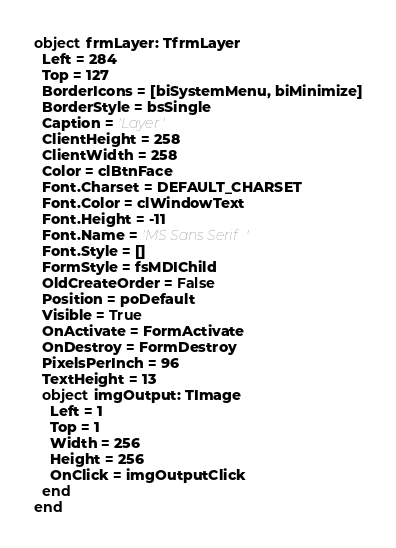<code> <loc_0><loc_0><loc_500><loc_500><_Pascal_>object frmLayer: TfrmLayer
  Left = 284
  Top = 127
  BorderIcons = [biSystemMenu, biMinimize]
  BorderStyle = bsSingle
  Caption = 'Layer'
  ClientHeight = 258
  ClientWidth = 258
  Color = clBtnFace
  Font.Charset = DEFAULT_CHARSET
  Font.Color = clWindowText
  Font.Height = -11
  Font.Name = 'MS Sans Serif'
  Font.Style = []
  FormStyle = fsMDIChild
  OldCreateOrder = False
  Position = poDefault
  Visible = True
  OnActivate = FormActivate
  OnDestroy = FormDestroy
  PixelsPerInch = 96
  TextHeight = 13
  object imgOutput: TImage
    Left = 1
    Top = 1
    Width = 256
    Height = 256
    OnClick = imgOutputClick
  end
end
</code> 